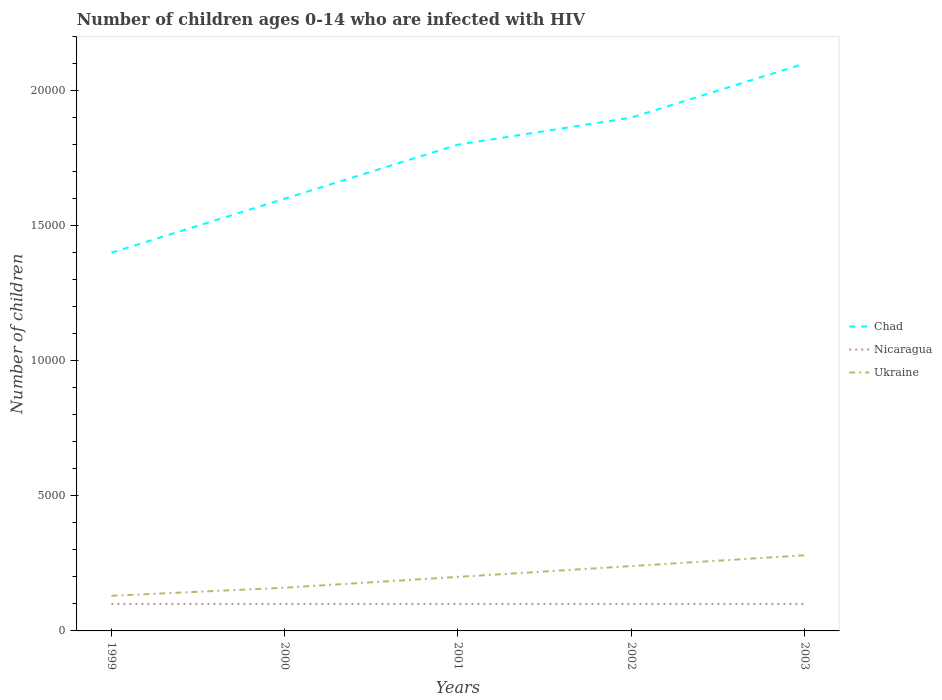Is the number of lines equal to the number of legend labels?
Make the answer very short. Yes. Across all years, what is the maximum number of HIV infected children in Ukraine?
Your answer should be very brief. 1300. What is the total number of HIV infected children in Ukraine in the graph?
Make the answer very short. -400. What is the difference between the highest and the second highest number of HIV infected children in Chad?
Provide a succinct answer. 7000. What is the difference between the highest and the lowest number of HIV infected children in Nicaragua?
Ensure brevity in your answer.  0. How many lines are there?
Give a very brief answer. 3. How many years are there in the graph?
Your response must be concise. 5. What is the difference between two consecutive major ticks on the Y-axis?
Offer a very short reply. 5000. Where does the legend appear in the graph?
Make the answer very short. Center right. What is the title of the graph?
Ensure brevity in your answer.  Number of children ages 0-14 who are infected with HIV. What is the label or title of the X-axis?
Your response must be concise. Years. What is the label or title of the Y-axis?
Your response must be concise. Number of children. What is the Number of children of Chad in 1999?
Give a very brief answer. 1.40e+04. What is the Number of children in Nicaragua in 1999?
Offer a terse response. 1000. What is the Number of children of Ukraine in 1999?
Provide a short and direct response. 1300. What is the Number of children of Chad in 2000?
Your answer should be very brief. 1.60e+04. What is the Number of children in Nicaragua in 2000?
Provide a succinct answer. 1000. What is the Number of children of Ukraine in 2000?
Provide a short and direct response. 1600. What is the Number of children of Chad in 2001?
Offer a terse response. 1.80e+04. What is the Number of children in Ukraine in 2001?
Your response must be concise. 2000. What is the Number of children in Chad in 2002?
Your answer should be compact. 1.90e+04. What is the Number of children in Nicaragua in 2002?
Offer a very short reply. 1000. What is the Number of children of Ukraine in 2002?
Offer a very short reply. 2400. What is the Number of children in Chad in 2003?
Offer a very short reply. 2.10e+04. What is the Number of children in Nicaragua in 2003?
Your response must be concise. 1000. What is the Number of children in Ukraine in 2003?
Give a very brief answer. 2800. Across all years, what is the maximum Number of children in Chad?
Your answer should be very brief. 2.10e+04. Across all years, what is the maximum Number of children in Ukraine?
Ensure brevity in your answer.  2800. Across all years, what is the minimum Number of children of Chad?
Your answer should be very brief. 1.40e+04. Across all years, what is the minimum Number of children of Nicaragua?
Your answer should be compact. 1000. Across all years, what is the minimum Number of children in Ukraine?
Give a very brief answer. 1300. What is the total Number of children in Chad in the graph?
Provide a succinct answer. 8.80e+04. What is the total Number of children of Ukraine in the graph?
Your answer should be very brief. 1.01e+04. What is the difference between the Number of children of Chad in 1999 and that in 2000?
Your response must be concise. -2000. What is the difference between the Number of children of Ukraine in 1999 and that in 2000?
Your response must be concise. -300. What is the difference between the Number of children in Chad in 1999 and that in 2001?
Offer a very short reply. -4000. What is the difference between the Number of children in Nicaragua in 1999 and that in 2001?
Provide a short and direct response. 0. What is the difference between the Number of children in Ukraine in 1999 and that in 2001?
Keep it short and to the point. -700. What is the difference between the Number of children of Chad in 1999 and that in 2002?
Provide a short and direct response. -5000. What is the difference between the Number of children of Nicaragua in 1999 and that in 2002?
Provide a succinct answer. 0. What is the difference between the Number of children of Ukraine in 1999 and that in 2002?
Give a very brief answer. -1100. What is the difference between the Number of children of Chad in 1999 and that in 2003?
Offer a very short reply. -7000. What is the difference between the Number of children in Nicaragua in 1999 and that in 2003?
Provide a short and direct response. 0. What is the difference between the Number of children in Ukraine in 1999 and that in 2003?
Make the answer very short. -1500. What is the difference between the Number of children in Chad in 2000 and that in 2001?
Make the answer very short. -2000. What is the difference between the Number of children of Ukraine in 2000 and that in 2001?
Provide a succinct answer. -400. What is the difference between the Number of children in Chad in 2000 and that in 2002?
Give a very brief answer. -3000. What is the difference between the Number of children in Nicaragua in 2000 and that in 2002?
Give a very brief answer. 0. What is the difference between the Number of children of Ukraine in 2000 and that in 2002?
Keep it short and to the point. -800. What is the difference between the Number of children of Chad in 2000 and that in 2003?
Your answer should be very brief. -5000. What is the difference between the Number of children in Ukraine in 2000 and that in 2003?
Make the answer very short. -1200. What is the difference between the Number of children of Chad in 2001 and that in 2002?
Offer a very short reply. -1000. What is the difference between the Number of children in Ukraine in 2001 and that in 2002?
Make the answer very short. -400. What is the difference between the Number of children of Chad in 2001 and that in 2003?
Your answer should be very brief. -3000. What is the difference between the Number of children of Nicaragua in 2001 and that in 2003?
Your answer should be compact. 0. What is the difference between the Number of children of Ukraine in 2001 and that in 2003?
Offer a terse response. -800. What is the difference between the Number of children of Chad in 2002 and that in 2003?
Offer a very short reply. -2000. What is the difference between the Number of children in Nicaragua in 2002 and that in 2003?
Offer a very short reply. 0. What is the difference between the Number of children of Ukraine in 2002 and that in 2003?
Make the answer very short. -400. What is the difference between the Number of children of Chad in 1999 and the Number of children of Nicaragua in 2000?
Your answer should be very brief. 1.30e+04. What is the difference between the Number of children of Chad in 1999 and the Number of children of Ukraine in 2000?
Make the answer very short. 1.24e+04. What is the difference between the Number of children in Nicaragua in 1999 and the Number of children in Ukraine in 2000?
Provide a short and direct response. -600. What is the difference between the Number of children of Chad in 1999 and the Number of children of Nicaragua in 2001?
Your response must be concise. 1.30e+04. What is the difference between the Number of children in Chad in 1999 and the Number of children in Ukraine in 2001?
Make the answer very short. 1.20e+04. What is the difference between the Number of children of Nicaragua in 1999 and the Number of children of Ukraine in 2001?
Give a very brief answer. -1000. What is the difference between the Number of children in Chad in 1999 and the Number of children in Nicaragua in 2002?
Give a very brief answer. 1.30e+04. What is the difference between the Number of children in Chad in 1999 and the Number of children in Ukraine in 2002?
Ensure brevity in your answer.  1.16e+04. What is the difference between the Number of children of Nicaragua in 1999 and the Number of children of Ukraine in 2002?
Your answer should be compact. -1400. What is the difference between the Number of children of Chad in 1999 and the Number of children of Nicaragua in 2003?
Provide a succinct answer. 1.30e+04. What is the difference between the Number of children in Chad in 1999 and the Number of children in Ukraine in 2003?
Provide a short and direct response. 1.12e+04. What is the difference between the Number of children of Nicaragua in 1999 and the Number of children of Ukraine in 2003?
Make the answer very short. -1800. What is the difference between the Number of children in Chad in 2000 and the Number of children in Nicaragua in 2001?
Keep it short and to the point. 1.50e+04. What is the difference between the Number of children of Chad in 2000 and the Number of children of Ukraine in 2001?
Give a very brief answer. 1.40e+04. What is the difference between the Number of children in Nicaragua in 2000 and the Number of children in Ukraine in 2001?
Your answer should be very brief. -1000. What is the difference between the Number of children of Chad in 2000 and the Number of children of Nicaragua in 2002?
Offer a terse response. 1.50e+04. What is the difference between the Number of children of Chad in 2000 and the Number of children of Ukraine in 2002?
Your answer should be very brief. 1.36e+04. What is the difference between the Number of children in Nicaragua in 2000 and the Number of children in Ukraine in 2002?
Provide a succinct answer. -1400. What is the difference between the Number of children of Chad in 2000 and the Number of children of Nicaragua in 2003?
Provide a short and direct response. 1.50e+04. What is the difference between the Number of children in Chad in 2000 and the Number of children in Ukraine in 2003?
Ensure brevity in your answer.  1.32e+04. What is the difference between the Number of children of Nicaragua in 2000 and the Number of children of Ukraine in 2003?
Ensure brevity in your answer.  -1800. What is the difference between the Number of children in Chad in 2001 and the Number of children in Nicaragua in 2002?
Make the answer very short. 1.70e+04. What is the difference between the Number of children of Chad in 2001 and the Number of children of Ukraine in 2002?
Offer a very short reply. 1.56e+04. What is the difference between the Number of children in Nicaragua in 2001 and the Number of children in Ukraine in 2002?
Ensure brevity in your answer.  -1400. What is the difference between the Number of children in Chad in 2001 and the Number of children in Nicaragua in 2003?
Provide a short and direct response. 1.70e+04. What is the difference between the Number of children of Chad in 2001 and the Number of children of Ukraine in 2003?
Your answer should be compact. 1.52e+04. What is the difference between the Number of children of Nicaragua in 2001 and the Number of children of Ukraine in 2003?
Offer a very short reply. -1800. What is the difference between the Number of children of Chad in 2002 and the Number of children of Nicaragua in 2003?
Your response must be concise. 1.80e+04. What is the difference between the Number of children of Chad in 2002 and the Number of children of Ukraine in 2003?
Give a very brief answer. 1.62e+04. What is the difference between the Number of children in Nicaragua in 2002 and the Number of children in Ukraine in 2003?
Your response must be concise. -1800. What is the average Number of children in Chad per year?
Your answer should be very brief. 1.76e+04. What is the average Number of children of Ukraine per year?
Provide a succinct answer. 2020. In the year 1999, what is the difference between the Number of children of Chad and Number of children of Nicaragua?
Provide a succinct answer. 1.30e+04. In the year 1999, what is the difference between the Number of children in Chad and Number of children in Ukraine?
Your answer should be very brief. 1.27e+04. In the year 1999, what is the difference between the Number of children in Nicaragua and Number of children in Ukraine?
Your response must be concise. -300. In the year 2000, what is the difference between the Number of children of Chad and Number of children of Nicaragua?
Your answer should be compact. 1.50e+04. In the year 2000, what is the difference between the Number of children in Chad and Number of children in Ukraine?
Provide a succinct answer. 1.44e+04. In the year 2000, what is the difference between the Number of children in Nicaragua and Number of children in Ukraine?
Your answer should be very brief. -600. In the year 2001, what is the difference between the Number of children of Chad and Number of children of Nicaragua?
Provide a succinct answer. 1.70e+04. In the year 2001, what is the difference between the Number of children of Chad and Number of children of Ukraine?
Keep it short and to the point. 1.60e+04. In the year 2001, what is the difference between the Number of children of Nicaragua and Number of children of Ukraine?
Your response must be concise. -1000. In the year 2002, what is the difference between the Number of children in Chad and Number of children in Nicaragua?
Give a very brief answer. 1.80e+04. In the year 2002, what is the difference between the Number of children of Chad and Number of children of Ukraine?
Make the answer very short. 1.66e+04. In the year 2002, what is the difference between the Number of children in Nicaragua and Number of children in Ukraine?
Your response must be concise. -1400. In the year 2003, what is the difference between the Number of children of Chad and Number of children of Nicaragua?
Give a very brief answer. 2.00e+04. In the year 2003, what is the difference between the Number of children of Chad and Number of children of Ukraine?
Make the answer very short. 1.82e+04. In the year 2003, what is the difference between the Number of children of Nicaragua and Number of children of Ukraine?
Keep it short and to the point. -1800. What is the ratio of the Number of children in Chad in 1999 to that in 2000?
Offer a terse response. 0.88. What is the ratio of the Number of children of Ukraine in 1999 to that in 2000?
Provide a short and direct response. 0.81. What is the ratio of the Number of children in Chad in 1999 to that in 2001?
Offer a very short reply. 0.78. What is the ratio of the Number of children in Ukraine in 1999 to that in 2001?
Your answer should be compact. 0.65. What is the ratio of the Number of children of Chad in 1999 to that in 2002?
Your response must be concise. 0.74. What is the ratio of the Number of children in Ukraine in 1999 to that in 2002?
Your answer should be compact. 0.54. What is the ratio of the Number of children of Chad in 1999 to that in 2003?
Make the answer very short. 0.67. What is the ratio of the Number of children of Nicaragua in 1999 to that in 2003?
Offer a terse response. 1. What is the ratio of the Number of children in Ukraine in 1999 to that in 2003?
Offer a terse response. 0.46. What is the ratio of the Number of children in Chad in 2000 to that in 2001?
Make the answer very short. 0.89. What is the ratio of the Number of children of Nicaragua in 2000 to that in 2001?
Ensure brevity in your answer.  1. What is the ratio of the Number of children in Ukraine in 2000 to that in 2001?
Your answer should be very brief. 0.8. What is the ratio of the Number of children of Chad in 2000 to that in 2002?
Your response must be concise. 0.84. What is the ratio of the Number of children in Ukraine in 2000 to that in 2002?
Your answer should be very brief. 0.67. What is the ratio of the Number of children of Chad in 2000 to that in 2003?
Ensure brevity in your answer.  0.76. What is the ratio of the Number of children in Nicaragua in 2000 to that in 2003?
Give a very brief answer. 1. What is the ratio of the Number of children of Ukraine in 2000 to that in 2003?
Offer a terse response. 0.57. What is the ratio of the Number of children in Chad in 2001 to that in 2002?
Provide a short and direct response. 0.95. What is the ratio of the Number of children in Nicaragua in 2001 to that in 2002?
Offer a very short reply. 1. What is the ratio of the Number of children in Ukraine in 2001 to that in 2002?
Ensure brevity in your answer.  0.83. What is the ratio of the Number of children in Chad in 2001 to that in 2003?
Provide a short and direct response. 0.86. What is the ratio of the Number of children of Ukraine in 2001 to that in 2003?
Your answer should be very brief. 0.71. What is the ratio of the Number of children in Chad in 2002 to that in 2003?
Your response must be concise. 0.9. What is the ratio of the Number of children in Ukraine in 2002 to that in 2003?
Your answer should be compact. 0.86. What is the difference between the highest and the second highest Number of children in Nicaragua?
Offer a very short reply. 0. What is the difference between the highest and the second highest Number of children in Ukraine?
Provide a succinct answer. 400. What is the difference between the highest and the lowest Number of children of Chad?
Give a very brief answer. 7000. What is the difference between the highest and the lowest Number of children of Nicaragua?
Your response must be concise. 0. What is the difference between the highest and the lowest Number of children in Ukraine?
Give a very brief answer. 1500. 